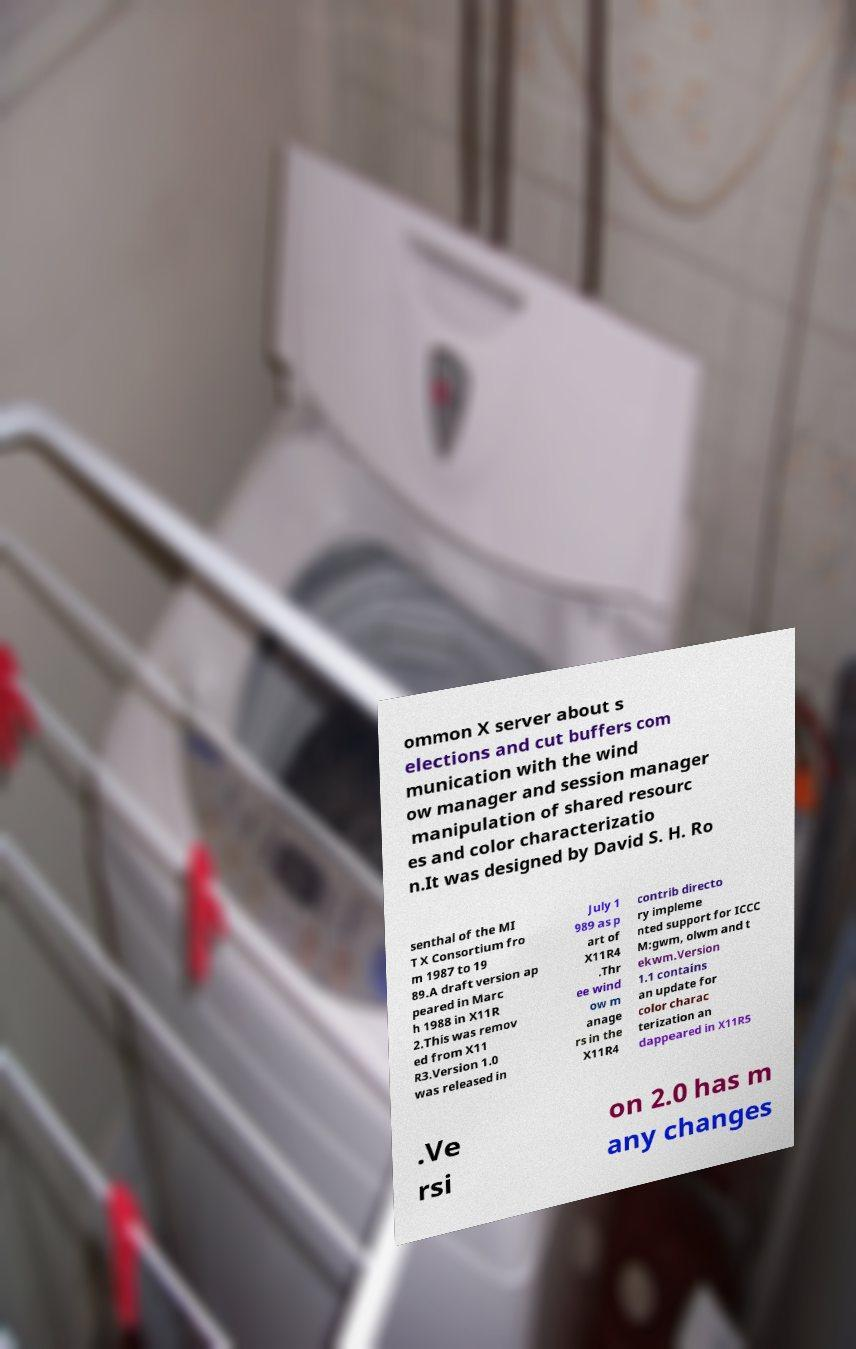Please identify and transcribe the text found in this image. ommon X server about s elections and cut buffers com munication with the wind ow manager and session manager manipulation of shared resourc es and color characterizatio n.It was designed by David S. H. Ro senthal of the MI T X Consortium fro m 1987 to 19 89.A draft version ap peared in Marc h 1988 in X11R 2.This was remov ed from X11 R3.Version 1.0 was released in July 1 989 as p art of X11R4 .Thr ee wind ow m anage rs in the X11R4 contrib directo ry impleme nted support for ICCC M:gwm, olwm and t ekwm.Version 1.1 contains an update for color charac terization an dappeared in X11R5 .Ve rsi on 2.0 has m any changes 